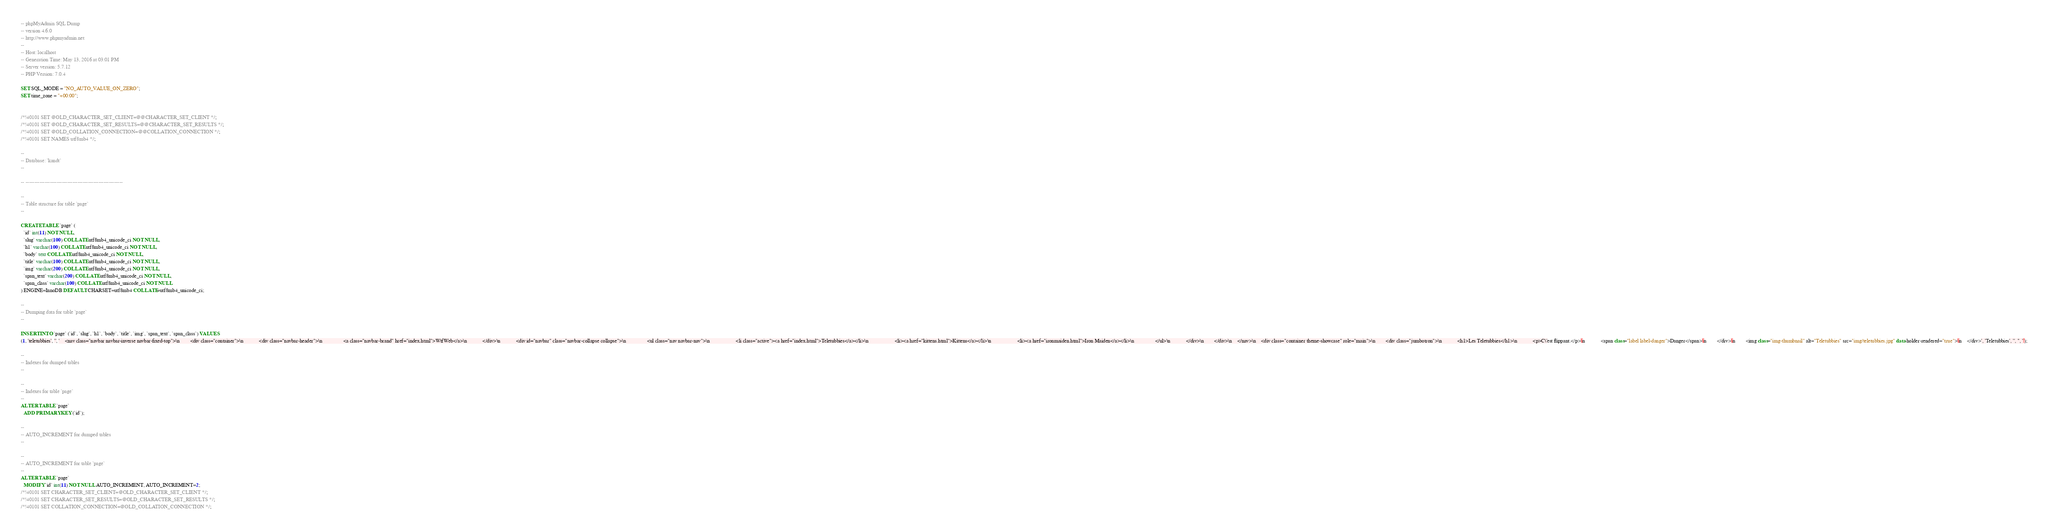Convert code to text. <code><loc_0><loc_0><loc_500><loc_500><_SQL_>-- phpMyAdmin SQL Dump
-- version 4.6.0
-- http://www.phpmyadmin.net
--
-- Host: localhost
-- Generation Time: May 13, 2016 at 03:01 PM
-- Server version: 5.7.12
-- PHP Version: 7.0.4

SET SQL_MODE = "NO_AUTO_VALUE_ON_ZERO";
SET time_zone = "+00:00";


/*!40101 SET @OLD_CHARACTER_SET_CLIENT=@@CHARACTER_SET_CLIENT */;
/*!40101 SET @OLD_CHARACTER_SET_RESULTS=@@CHARACTER_SET_RESULTS */;
/*!40101 SET @OLD_COLLATION_CONNECTION=@@COLLATION_CONNECTION */;
/*!40101 SET NAMES utf8mb4 */;

--
-- Database: `kandt`
--

-- --------------------------------------------------------

--
-- Table structure for table `page`
--

CREATE TABLE `page` (
  `id` int(11) NOT NULL,
  `slug` varchar(100) COLLATE utf8mb4_unicode_ci NOT NULL,
  `h1` varchar(100) COLLATE utf8mb4_unicode_ci NOT NULL,
  `body` text COLLATE utf8mb4_unicode_ci NOT NULL,
  `title` varchar(100) COLLATE utf8mb4_unicode_ci NOT NULL,
  `img` varchar(200) COLLATE utf8mb4_unicode_ci NOT NULL,
  `span_text` varchar(200) COLLATE utf8mb4_unicode_ci NOT NULL,
  `span_class` varchar(100) COLLATE utf8mb4_unicode_ci NOT NULL
) ENGINE=InnoDB DEFAULT CHARSET=utf8mb4 COLLATE=utf8mb4_unicode_ci;

--
-- Dumping data for table `page`
--

INSERT INTO `page` (`id`, `slug`, `h1`, `body`, `title`, `img`, `span_text`, `span_class`) VALUES
(1, 'teletubbies', '', '    <nav class="navbar navbar-inverse navbar-fixed-top">\n        <div class="container">\n            <div class="navbar-header">\n                <a class="navbar-brand" href="index.html">WtfWeb</a>\n            </div>\n            <div id="navbar" class="navbar-collapse collapse">\n                <ul class="nav navbar-nav">\n                    <li class="active"><a href="index.html">Teletubbies</a></li>\n                    <li><a href="kittens.html">Kittens</a></li>\n                    <li><a href="ironmaiden.html">Iron Maiden</a></li>\n                </ul>\n            </div>\n        </div>\n    </nav>\n    <div class="container theme-showcase" role="main">\n        <div class="jumbotron">\n            <h1>Les Teletubbies</h1>\n            <p>C\'est flippant.</p>\n            <span class="label label-danger">Danger</span>\n        </div>\n        <img class="img-thumbnail" alt="Teletubbies" src="img/teletubbies.jpg" data-holder-rendered="true">\n    </div>', 'Teletubbies', '', '', '');

--
-- Indexes for dumped tables
--

--
-- Indexes for table `page`
--
ALTER TABLE `page`
  ADD PRIMARY KEY (`id`);

--
-- AUTO_INCREMENT for dumped tables
--

--
-- AUTO_INCREMENT for table `page`
--
ALTER TABLE `page`
  MODIFY `id` int(11) NOT NULL AUTO_INCREMENT, AUTO_INCREMENT=2;
/*!40101 SET CHARACTER_SET_CLIENT=@OLD_CHARACTER_SET_CLIENT */;
/*!40101 SET CHARACTER_SET_RESULTS=@OLD_CHARACTER_SET_RESULTS */;
/*!40101 SET COLLATION_CONNECTION=@OLD_COLLATION_CONNECTION */;
</code> 